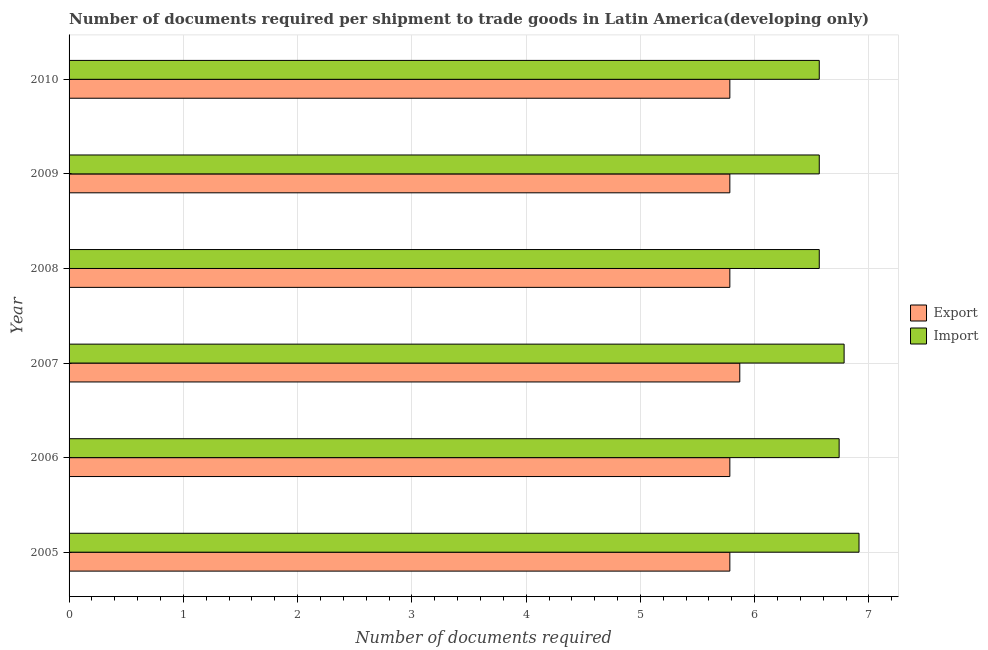How many different coloured bars are there?
Ensure brevity in your answer.  2. How many groups of bars are there?
Ensure brevity in your answer.  6. Are the number of bars per tick equal to the number of legend labels?
Your response must be concise. Yes. Are the number of bars on each tick of the Y-axis equal?
Your answer should be compact. Yes. How many bars are there on the 1st tick from the bottom?
Your answer should be very brief. 2. In how many cases, is the number of bars for a given year not equal to the number of legend labels?
Give a very brief answer. 0. What is the number of documents required to import goods in 2007?
Provide a succinct answer. 6.78. Across all years, what is the maximum number of documents required to export goods?
Give a very brief answer. 5.87. Across all years, what is the minimum number of documents required to export goods?
Ensure brevity in your answer.  5.78. What is the total number of documents required to export goods in the graph?
Your answer should be compact. 34.78. What is the difference between the number of documents required to import goods in 2008 and the number of documents required to export goods in 2005?
Your response must be concise. 0.78. What is the average number of documents required to export goods per year?
Your answer should be compact. 5.8. In how many years, is the number of documents required to export goods greater than 6 ?
Provide a succinct answer. 0. What is the ratio of the number of documents required to export goods in 2005 to that in 2008?
Provide a succinct answer. 1. Is the number of documents required to import goods in 2008 less than that in 2009?
Offer a very short reply. No. What is the difference between the highest and the second highest number of documents required to export goods?
Give a very brief answer. 0.09. In how many years, is the number of documents required to import goods greater than the average number of documents required to import goods taken over all years?
Offer a very short reply. 3. Is the sum of the number of documents required to import goods in 2005 and 2009 greater than the maximum number of documents required to export goods across all years?
Your answer should be compact. Yes. What does the 2nd bar from the top in 2008 represents?
Keep it short and to the point. Export. What does the 2nd bar from the bottom in 2008 represents?
Ensure brevity in your answer.  Import. How many bars are there?
Provide a succinct answer. 12. How many years are there in the graph?
Provide a succinct answer. 6. What is the difference between two consecutive major ticks on the X-axis?
Your answer should be very brief. 1. Does the graph contain any zero values?
Keep it short and to the point. No. Does the graph contain grids?
Offer a very short reply. Yes. How many legend labels are there?
Give a very brief answer. 2. How are the legend labels stacked?
Offer a very short reply. Vertical. What is the title of the graph?
Provide a short and direct response. Number of documents required per shipment to trade goods in Latin America(developing only). Does "International Tourists" appear as one of the legend labels in the graph?
Provide a succinct answer. No. What is the label or title of the X-axis?
Offer a very short reply. Number of documents required. What is the label or title of the Y-axis?
Offer a terse response. Year. What is the Number of documents required in Export in 2005?
Offer a very short reply. 5.78. What is the Number of documents required of Import in 2005?
Your answer should be very brief. 6.91. What is the Number of documents required of Export in 2006?
Your answer should be compact. 5.78. What is the Number of documents required of Import in 2006?
Make the answer very short. 6.74. What is the Number of documents required in Export in 2007?
Provide a short and direct response. 5.87. What is the Number of documents required in Import in 2007?
Offer a terse response. 6.78. What is the Number of documents required of Export in 2008?
Your answer should be very brief. 5.78. What is the Number of documents required of Import in 2008?
Keep it short and to the point. 6.57. What is the Number of documents required in Export in 2009?
Your answer should be compact. 5.78. What is the Number of documents required in Import in 2009?
Offer a terse response. 6.57. What is the Number of documents required in Export in 2010?
Give a very brief answer. 5.78. What is the Number of documents required in Import in 2010?
Your answer should be compact. 6.57. Across all years, what is the maximum Number of documents required in Export?
Your response must be concise. 5.87. Across all years, what is the maximum Number of documents required of Import?
Provide a succinct answer. 6.91. Across all years, what is the minimum Number of documents required of Export?
Your response must be concise. 5.78. Across all years, what is the minimum Number of documents required of Import?
Provide a short and direct response. 6.57. What is the total Number of documents required in Export in the graph?
Your answer should be very brief. 34.78. What is the total Number of documents required of Import in the graph?
Your answer should be very brief. 40.13. What is the difference between the Number of documents required of Import in 2005 and that in 2006?
Keep it short and to the point. 0.17. What is the difference between the Number of documents required of Export in 2005 and that in 2007?
Offer a terse response. -0.09. What is the difference between the Number of documents required of Import in 2005 and that in 2007?
Provide a succinct answer. 0.13. What is the difference between the Number of documents required in Export in 2005 and that in 2008?
Provide a short and direct response. 0. What is the difference between the Number of documents required of Import in 2005 and that in 2008?
Give a very brief answer. 0.35. What is the difference between the Number of documents required of Import in 2005 and that in 2009?
Your response must be concise. 0.35. What is the difference between the Number of documents required in Export in 2005 and that in 2010?
Ensure brevity in your answer.  0. What is the difference between the Number of documents required of Import in 2005 and that in 2010?
Make the answer very short. 0.35. What is the difference between the Number of documents required of Export in 2006 and that in 2007?
Your answer should be compact. -0.09. What is the difference between the Number of documents required in Import in 2006 and that in 2007?
Provide a short and direct response. -0.04. What is the difference between the Number of documents required of Import in 2006 and that in 2008?
Your response must be concise. 0.17. What is the difference between the Number of documents required in Import in 2006 and that in 2009?
Your answer should be compact. 0.17. What is the difference between the Number of documents required of Export in 2006 and that in 2010?
Your answer should be compact. 0. What is the difference between the Number of documents required of Import in 2006 and that in 2010?
Your response must be concise. 0.17. What is the difference between the Number of documents required in Export in 2007 and that in 2008?
Make the answer very short. 0.09. What is the difference between the Number of documents required in Import in 2007 and that in 2008?
Ensure brevity in your answer.  0.22. What is the difference between the Number of documents required in Export in 2007 and that in 2009?
Make the answer very short. 0.09. What is the difference between the Number of documents required of Import in 2007 and that in 2009?
Offer a very short reply. 0.22. What is the difference between the Number of documents required of Export in 2007 and that in 2010?
Keep it short and to the point. 0.09. What is the difference between the Number of documents required of Import in 2007 and that in 2010?
Your response must be concise. 0.22. What is the difference between the Number of documents required of Export in 2008 and that in 2009?
Your answer should be very brief. 0. What is the difference between the Number of documents required in Import in 2009 and that in 2010?
Provide a short and direct response. 0. What is the difference between the Number of documents required in Export in 2005 and the Number of documents required in Import in 2006?
Your response must be concise. -0.96. What is the difference between the Number of documents required in Export in 2005 and the Number of documents required in Import in 2008?
Make the answer very short. -0.78. What is the difference between the Number of documents required in Export in 2005 and the Number of documents required in Import in 2009?
Your response must be concise. -0.78. What is the difference between the Number of documents required in Export in 2005 and the Number of documents required in Import in 2010?
Your answer should be compact. -0.78. What is the difference between the Number of documents required in Export in 2006 and the Number of documents required in Import in 2008?
Provide a succinct answer. -0.78. What is the difference between the Number of documents required in Export in 2006 and the Number of documents required in Import in 2009?
Give a very brief answer. -0.78. What is the difference between the Number of documents required of Export in 2006 and the Number of documents required of Import in 2010?
Offer a very short reply. -0.78. What is the difference between the Number of documents required in Export in 2007 and the Number of documents required in Import in 2008?
Ensure brevity in your answer.  -0.7. What is the difference between the Number of documents required of Export in 2007 and the Number of documents required of Import in 2009?
Provide a short and direct response. -0.7. What is the difference between the Number of documents required in Export in 2007 and the Number of documents required in Import in 2010?
Offer a terse response. -0.7. What is the difference between the Number of documents required in Export in 2008 and the Number of documents required in Import in 2009?
Make the answer very short. -0.78. What is the difference between the Number of documents required in Export in 2008 and the Number of documents required in Import in 2010?
Provide a succinct answer. -0.78. What is the difference between the Number of documents required of Export in 2009 and the Number of documents required of Import in 2010?
Offer a very short reply. -0.78. What is the average Number of documents required of Export per year?
Your answer should be compact. 5.8. What is the average Number of documents required of Import per year?
Your answer should be very brief. 6.69. In the year 2005, what is the difference between the Number of documents required in Export and Number of documents required in Import?
Provide a short and direct response. -1.13. In the year 2006, what is the difference between the Number of documents required of Export and Number of documents required of Import?
Provide a short and direct response. -0.96. In the year 2007, what is the difference between the Number of documents required of Export and Number of documents required of Import?
Make the answer very short. -0.91. In the year 2008, what is the difference between the Number of documents required of Export and Number of documents required of Import?
Your response must be concise. -0.78. In the year 2009, what is the difference between the Number of documents required in Export and Number of documents required in Import?
Offer a terse response. -0.78. In the year 2010, what is the difference between the Number of documents required in Export and Number of documents required in Import?
Make the answer very short. -0.78. What is the ratio of the Number of documents required in Export in 2005 to that in 2006?
Make the answer very short. 1. What is the ratio of the Number of documents required in Import in 2005 to that in 2006?
Provide a succinct answer. 1.03. What is the ratio of the Number of documents required in Export in 2005 to that in 2007?
Ensure brevity in your answer.  0.99. What is the ratio of the Number of documents required of Import in 2005 to that in 2007?
Make the answer very short. 1.02. What is the ratio of the Number of documents required in Export in 2005 to that in 2008?
Provide a succinct answer. 1. What is the ratio of the Number of documents required of Import in 2005 to that in 2008?
Your response must be concise. 1.05. What is the ratio of the Number of documents required of Export in 2005 to that in 2009?
Ensure brevity in your answer.  1. What is the ratio of the Number of documents required of Import in 2005 to that in 2009?
Provide a short and direct response. 1.05. What is the ratio of the Number of documents required of Import in 2005 to that in 2010?
Make the answer very short. 1.05. What is the ratio of the Number of documents required in Export in 2006 to that in 2007?
Ensure brevity in your answer.  0.99. What is the ratio of the Number of documents required of Import in 2006 to that in 2007?
Make the answer very short. 0.99. What is the ratio of the Number of documents required of Import in 2006 to that in 2008?
Provide a succinct answer. 1.03. What is the ratio of the Number of documents required in Import in 2006 to that in 2009?
Your response must be concise. 1.03. What is the ratio of the Number of documents required in Import in 2006 to that in 2010?
Offer a terse response. 1.03. What is the ratio of the Number of documents required in Import in 2007 to that in 2008?
Give a very brief answer. 1.03. What is the ratio of the Number of documents required in Import in 2007 to that in 2009?
Give a very brief answer. 1.03. What is the ratio of the Number of documents required in Export in 2007 to that in 2010?
Make the answer very short. 1.01. What is the ratio of the Number of documents required in Import in 2007 to that in 2010?
Your answer should be compact. 1.03. What is the ratio of the Number of documents required in Import in 2009 to that in 2010?
Offer a very short reply. 1. What is the difference between the highest and the second highest Number of documents required in Export?
Your answer should be very brief. 0.09. What is the difference between the highest and the second highest Number of documents required of Import?
Your response must be concise. 0.13. What is the difference between the highest and the lowest Number of documents required in Export?
Make the answer very short. 0.09. What is the difference between the highest and the lowest Number of documents required in Import?
Give a very brief answer. 0.35. 